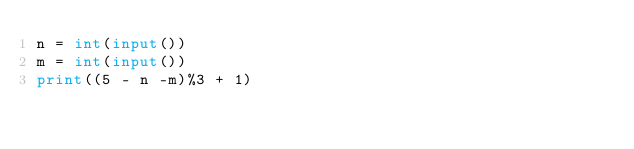<code> <loc_0><loc_0><loc_500><loc_500><_Python_>n = int(input())
m = int(input())
print((5 - n -m)%3 + 1)</code> 